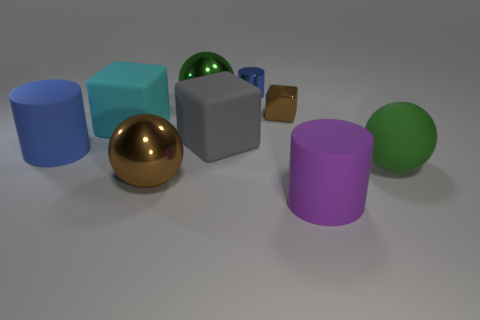There is a object that is the same color as the large rubber ball; what is it made of?
Keep it short and to the point. Metal. How many things are either large rubber cylinders that are behind the purple rubber cylinder or large objects to the right of the blue rubber cylinder?
Make the answer very short. 7. Are there more things that are behind the big blue cylinder than green rubber objects?
Provide a succinct answer. Yes. What number of other objects are the same shape as the green shiny thing?
Your response must be concise. 2. There is a sphere that is in front of the large gray object and behind the big brown sphere; what is its material?
Provide a short and direct response. Rubber. What number of objects are small brown cubes or purple matte cylinders?
Make the answer very short. 2. Is the number of green balls greater than the number of big green matte things?
Your answer should be compact. Yes. There is a blue thing that is left of the large metallic ball that is in front of the green rubber thing; what size is it?
Provide a short and direct response. Large. What color is the other big thing that is the same shape as the big blue rubber thing?
Ensure brevity in your answer.  Purple. How big is the gray cube?
Provide a succinct answer. Large. 